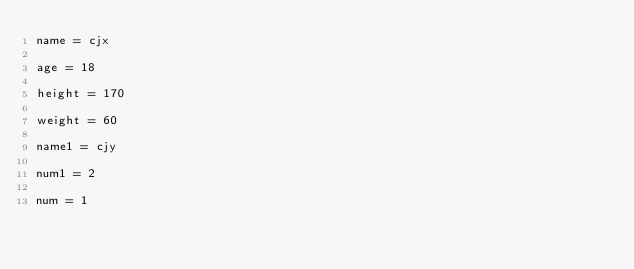<code> <loc_0><loc_0><loc_500><loc_500><_Python_>name = cjx

age = 18

height = 170

weight = 60

name1 = cjy

num1 = 2

num = 1
</code> 